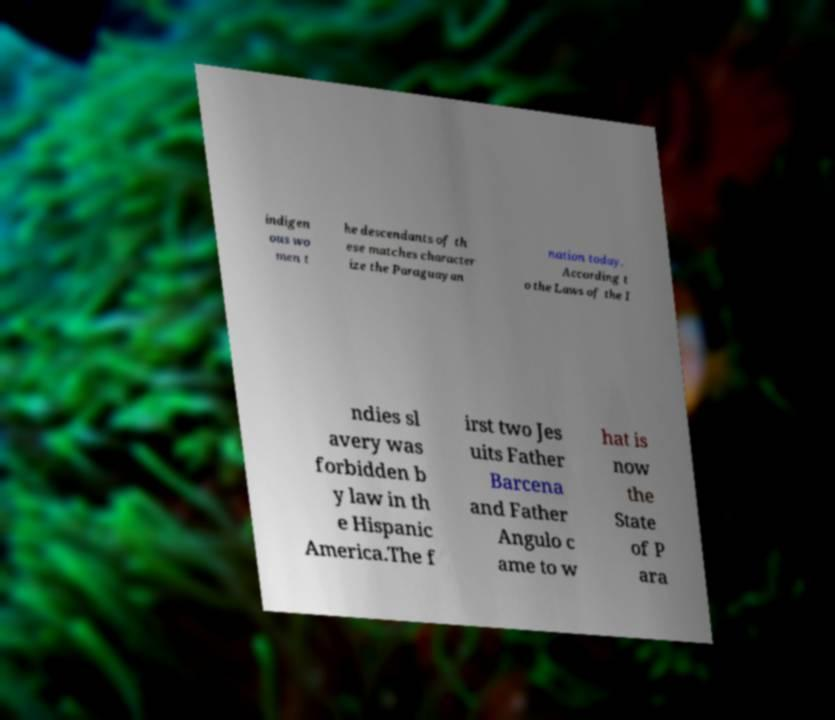Please identify and transcribe the text found in this image. indigen ous wo men t he descendants of th ese matches character ize the Paraguayan nation today. According t o the Laws of the I ndies sl avery was forbidden b y law in th e Hispanic America.The f irst two Jes uits Father Barcena and Father Angulo c ame to w hat is now the State of P ara 